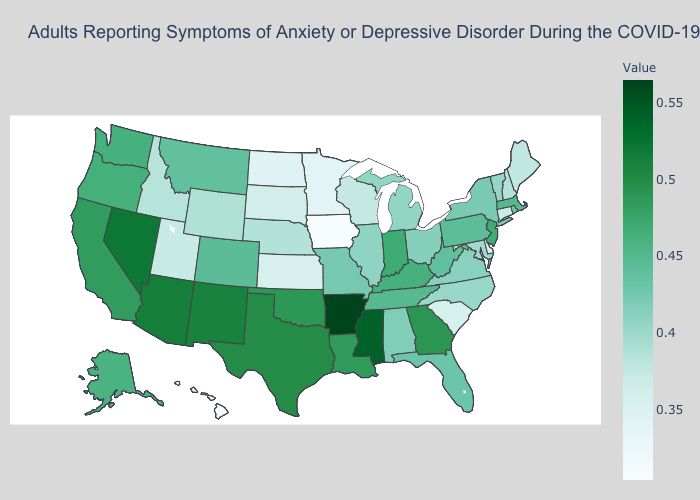Does Nebraska have a higher value than North Dakota?
Give a very brief answer. Yes. Does Oregon have the highest value in the USA?
Write a very short answer. No. Among the states that border Illinois , does Iowa have the lowest value?
Short answer required. Yes. Is the legend a continuous bar?
Quick response, please. Yes. Among the states that border Montana , which have the highest value?
Concise answer only. Wyoming. Among the states that border Illinois , which have the highest value?
Concise answer only. Indiana. Among the states that border Vermont , which have the lowest value?
Keep it brief. New Hampshire. Does New York have the highest value in the Northeast?
Answer briefly. No. 